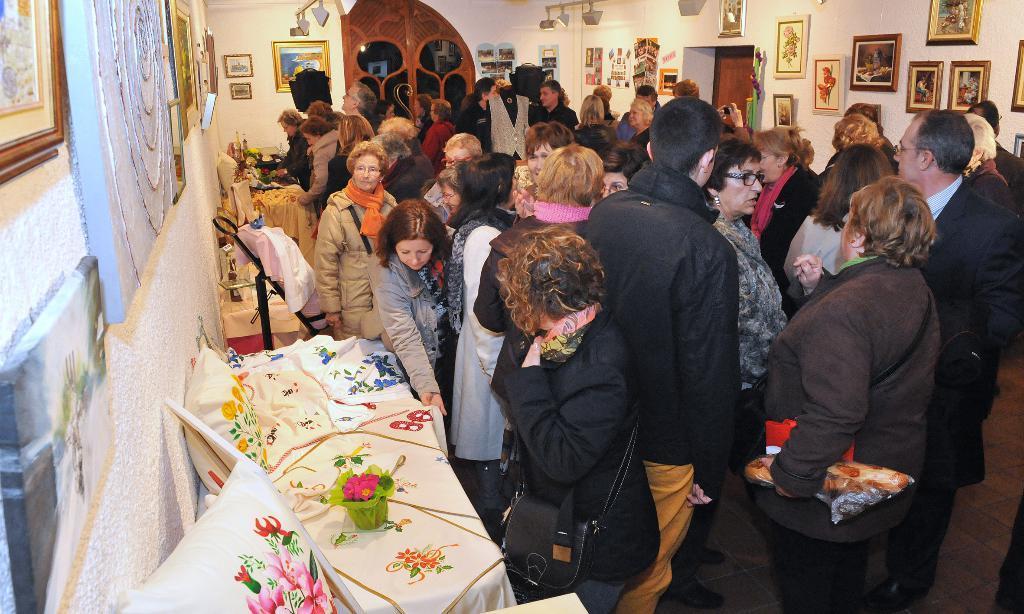How would you summarize this image in a sentence or two? This is an inside view of a room. Here I can see a crowd of people standing on the floor. On the left side there is a wall on which some photo frames are attached. Beside the wall there are some tables covered with white color clothes. On the tables, I can see few pillows and some other objects. In the background, I can see many photo frames are attached to the wall. 